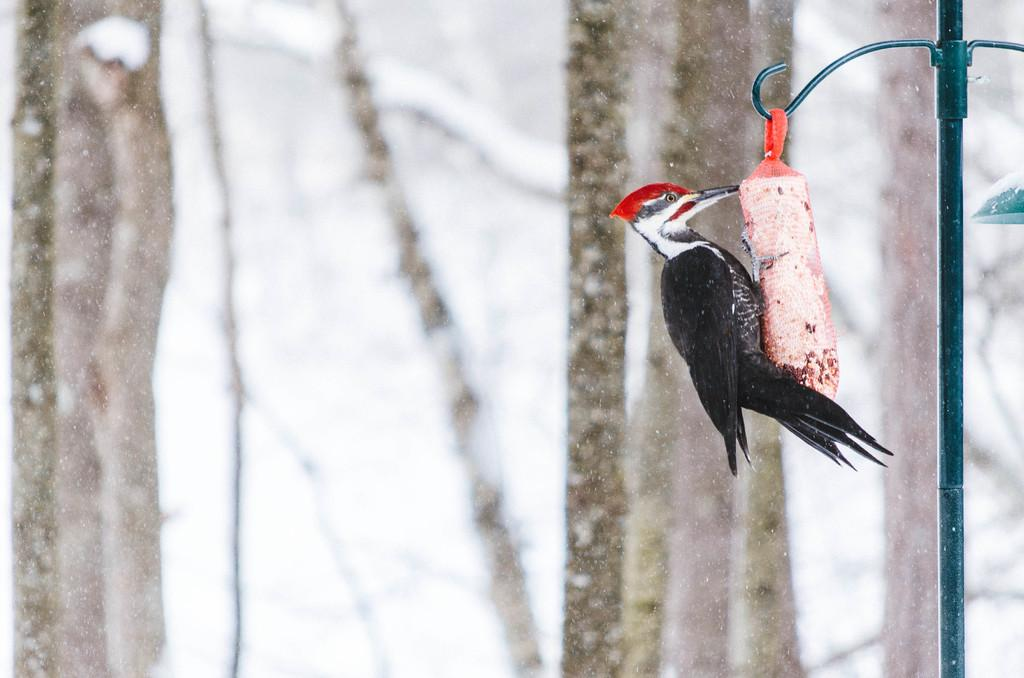What is located on the right side of the image? There is a board on some object on the right side of the image. What can be seen in the image besides the board? There is a pole in the image. What is visible in the background of the image? There are trees and snow visible in the background of the image. What type of bird can be seen flying over the park in the image? There is no bird or park present in the image. What type of fang can be seen in the image? There are no fangs present in the image. 